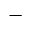Convert formula to latex. <formula><loc_0><loc_0><loc_500><loc_500>-</formula> 